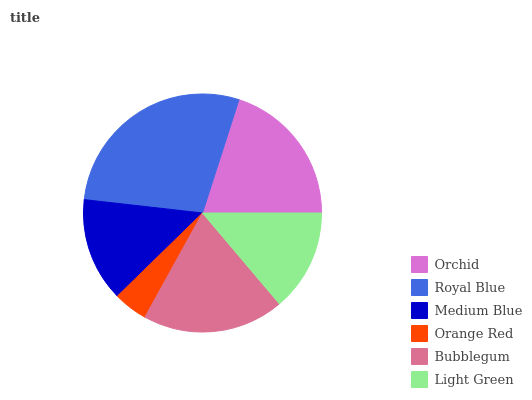Is Orange Red the minimum?
Answer yes or no. Yes. Is Royal Blue the maximum?
Answer yes or no. Yes. Is Medium Blue the minimum?
Answer yes or no. No. Is Medium Blue the maximum?
Answer yes or no. No. Is Royal Blue greater than Medium Blue?
Answer yes or no. Yes. Is Medium Blue less than Royal Blue?
Answer yes or no. Yes. Is Medium Blue greater than Royal Blue?
Answer yes or no. No. Is Royal Blue less than Medium Blue?
Answer yes or no. No. Is Bubblegum the high median?
Answer yes or no. Yes. Is Medium Blue the low median?
Answer yes or no. Yes. Is Orange Red the high median?
Answer yes or no. No. Is Royal Blue the low median?
Answer yes or no. No. 